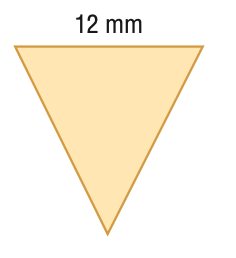Answer the mathemtical geometry problem and directly provide the correct option letter.
Question: Find the area of the regular polygon. Round to the nearest tenth.
Choices: A: 31.2 B: 62.4 C: 124.8 D: 144 B 